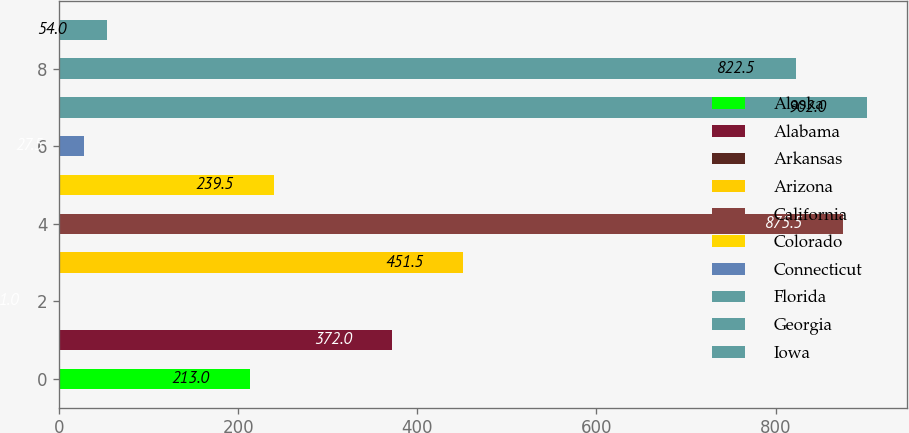Convert chart to OTSL. <chart><loc_0><loc_0><loc_500><loc_500><bar_chart><fcel>Alaska<fcel>Alabama<fcel>Arkansas<fcel>Arizona<fcel>California<fcel>Colorado<fcel>Connecticut<fcel>Florida<fcel>Georgia<fcel>Iowa<nl><fcel>213<fcel>372<fcel>1<fcel>451.5<fcel>875.5<fcel>239.5<fcel>27.5<fcel>902<fcel>822.5<fcel>54<nl></chart> 